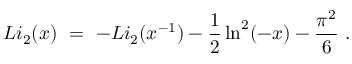Convert formula to latex. <formula><loc_0><loc_0><loc_500><loc_500>L i _ { 2 } ( x ) \ = \ - L i _ { 2 } ( x ^ { - 1 } ) - { \frac { 1 } { 2 } } \ln ^ { 2 } ( - x ) - { \frac { \pi ^ { 2 } } { 6 } } \ .</formula> 